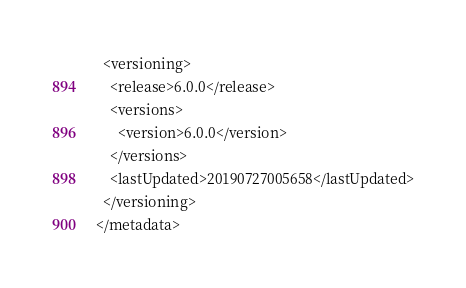<code> <loc_0><loc_0><loc_500><loc_500><_XML_>  <versioning>
    <release>6.0.0</release>
    <versions>
      <version>6.0.0</version>
    </versions>
    <lastUpdated>20190727005658</lastUpdated>
  </versioning>
</metadata>
</code> 